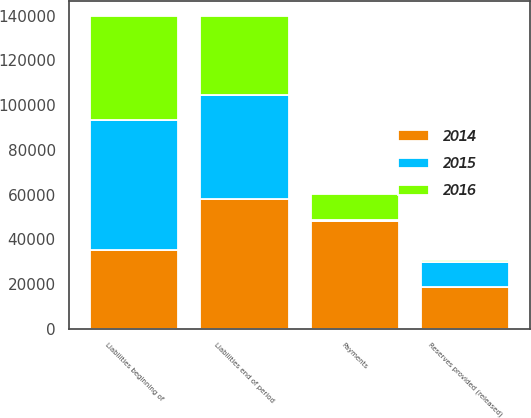<chart> <loc_0><loc_0><loc_500><loc_500><stacked_bar_chart><ecel><fcel>Liabilities beginning of<fcel>Reserves provided (released)<fcel>Payments<fcel>Liabilities end of period<nl><fcel>2016<fcel>46381<fcel>506<fcel>11773<fcel>35114<nl><fcel>2015<fcel>58222<fcel>11433<fcel>408<fcel>46381<nl><fcel>2014<fcel>35114<fcel>18604<fcel>48130<fcel>58222<nl></chart> 